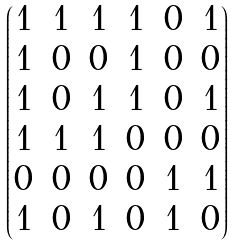Convert formula to latex. <formula><loc_0><loc_0><loc_500><loc_500>\begin{pmatrix} 1 & 1 & 1 & 1 & 0 & 1 \\ 1 & 0 & 0 & 1 & 0 & 0 \\ 1 & 0 & 1 & 1 & 0 & 1 \\ 1 & 1 & 1 & 0 & 0 & 0 \\ 0 & 0 & 0 & 0 & 1 & 1 \\ 1 & 0 & 1 & 0 & 1 & 0 \end{pmatrix}</formula> 